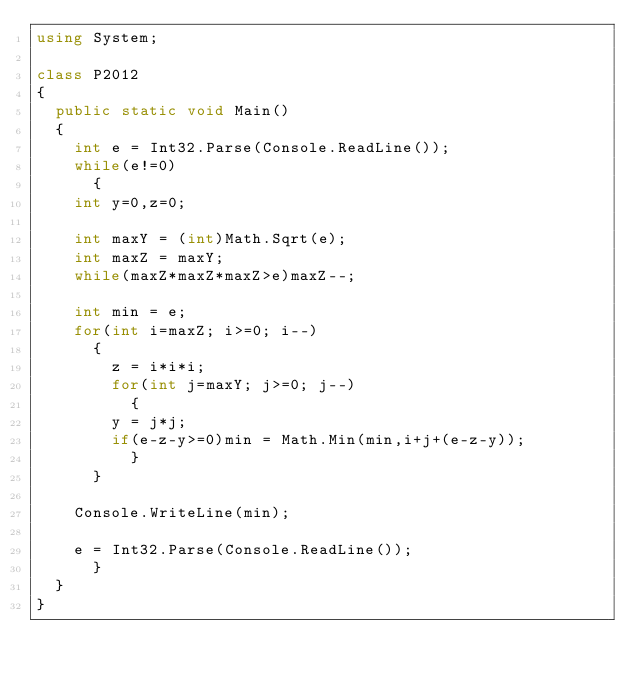Convert code to text. <code><loc_0><loc_0><loc_500><loc_500><_C#_>using System;

class P2012
{
  public static void Main()
  {
    int e = Int32.Parse(Console.ReadLine());
    while(e!=0)
      {
	int y=0,z=0;

	int maxY = (int)Math.Sqrt(e);
	int maxZ = maxY;
	while(maxZ*maxZ*maxZ>e)maxZ--;

	int min = e;
	for(int i=maxZ; i>=0; i--)
	  {
	    z = i*i*i;
	    for(int j=maxY; j>=0; j--)
	      {
		y = j*j;
		if(e-z-y>=0)min = Math.Min(min,i+j+(e-z-y));	
	      }
	  }

	Console.WriteLine(min);

	e = Int32.Parse(Console.ReadLine());
      }
  }
}</code> 